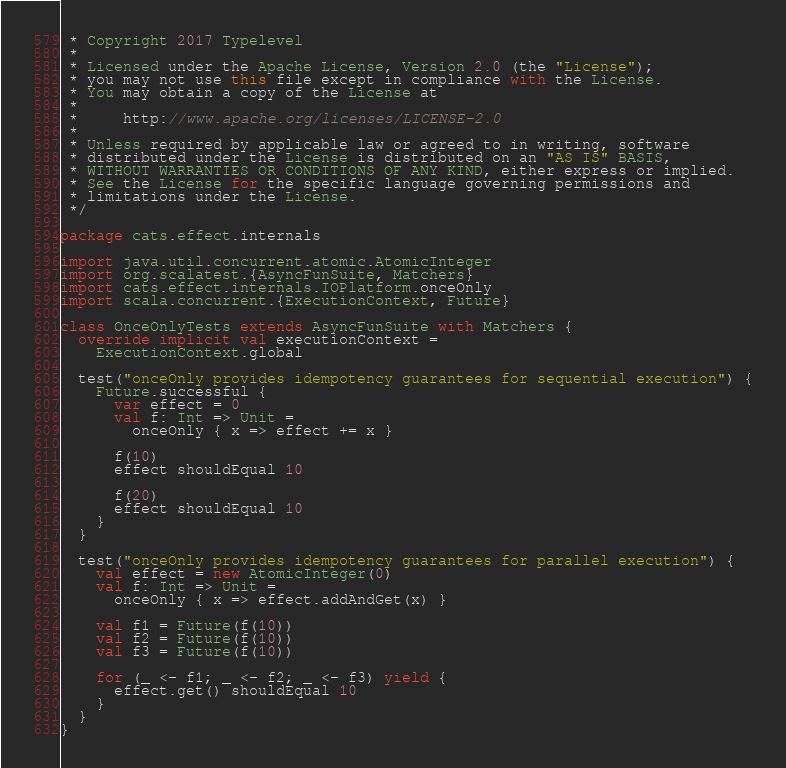<code> <loc_0><loc_0><loc_500><loc_500><_Scala_> * Copyright 2017 Typelevel
 *
 * Licensed under the Apache License, Version 2.0 (the "License");
 * you may not use this file except in compliance with the License.
 * You may obtain a copy of the License at
 *
 *     http://www.apache.org/licenses/LICENSE-2.0
 *
 * Unless required by applicable law or agreed to in writing, software
 * distributed under the License is distributed on an "AS IS" BASIS,
 * WITHOUT WARRANTIES OR CONDITIONS OF ANY KIND, either express or implied.
 * See the License for the specific language governing permissions and
 * limitations under the License.
 */

package cats.effect.internals

import java.util.concurrent.atomic.AtomicInteger
import org.scalatest.{AsyncFunSuite, Matchers}
import cats.effect.internals.IOPlatform.onceOnly
import scala.concurrent.{ExecutionContext, Future}

class OnceOnlyTests extends AsyncFunSuite with Matchers {
  override implicit val executionContext =
    ExecutionContext.global

  test("onceOnly provides idempotency guarantees for sequential execution") {
    Future.successful {
      var effect = 0
      val f: Int => Unit =
        onceOnly { x => effect += x }

      f(10)
      effect shouldEqual 10

      f(20)
      effect shouldEqual 10
    }
  }

  test("onceOnly provides idempotency guarantees for parallel execution") {
    val effect = new AtomicInteger(0)
    val f: Int => Unit =
      onceOnly { x => effect.addAndGet(x) }

    val f1 = Future(f(10))
    val f2 = Future(f(10))
    val f3 = Future(f(10))

    for (_ <- f1; _ <- f2; _ <- f3) yield {
      effect.get() shouldEqual 10
    }
  }
}
</code> 